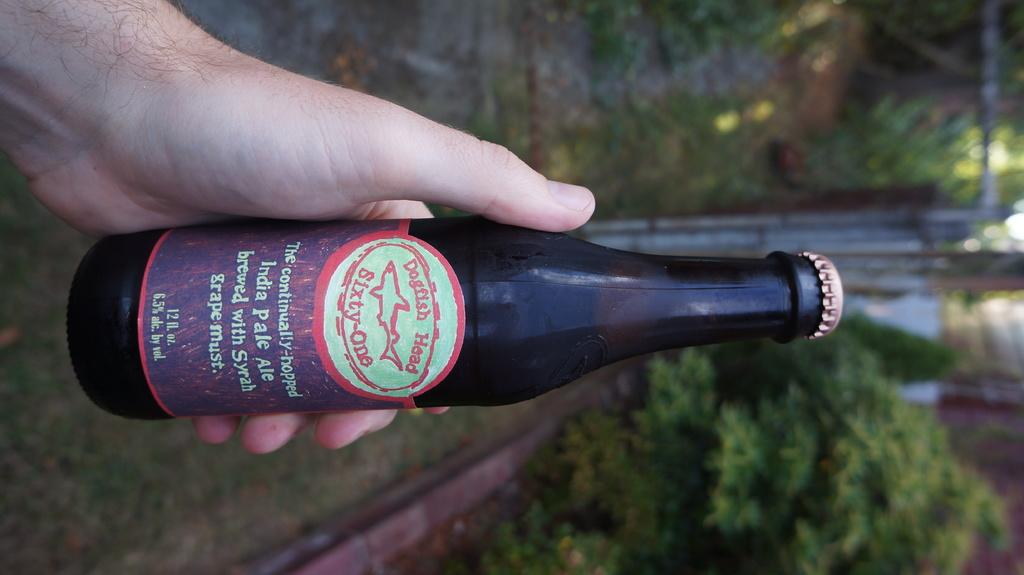<image>
Relay a brief, clear account of the picture shown. Someone holds a bottle of Dogfish Head Sixty-One India Pale Ale in an outdoor setting. 